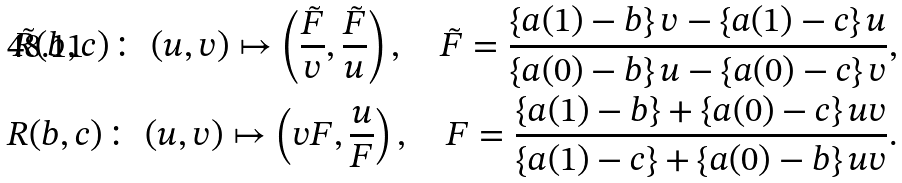Convert formula to latex. <formula><loc_0><loc_0><loc_500><loc_500>\tilde { R } ( b , c ) \colon \ ( u , v ) \mapsto \left ( \frac { \tilde { F } } { v } , \frac { \tilde { F } } { u } \right ) , \quad \tilde { F } = \frac { \left \{ a ( 1 ) - b \right \} v - \left \{ a ( 1 ) - c \right \} u } { \left \{ a ( 0 ) - b \right \} u - \left \{ a ( 0 ) - c \right \} v } , \\ R ( b , c ) \colon \ ( u , v ) \mapsto \left ( v F , \frac { u } { F } \right ) , \quad F = \frac { \left \{ a ( 1 ) - b \right \} + \left \{ a ( 0 ) - c \right \} u v } { \left \{ a ( 1 ) - c \right \} + \left \{ a ( 0 ) - b \right \} u v } .</formula> 